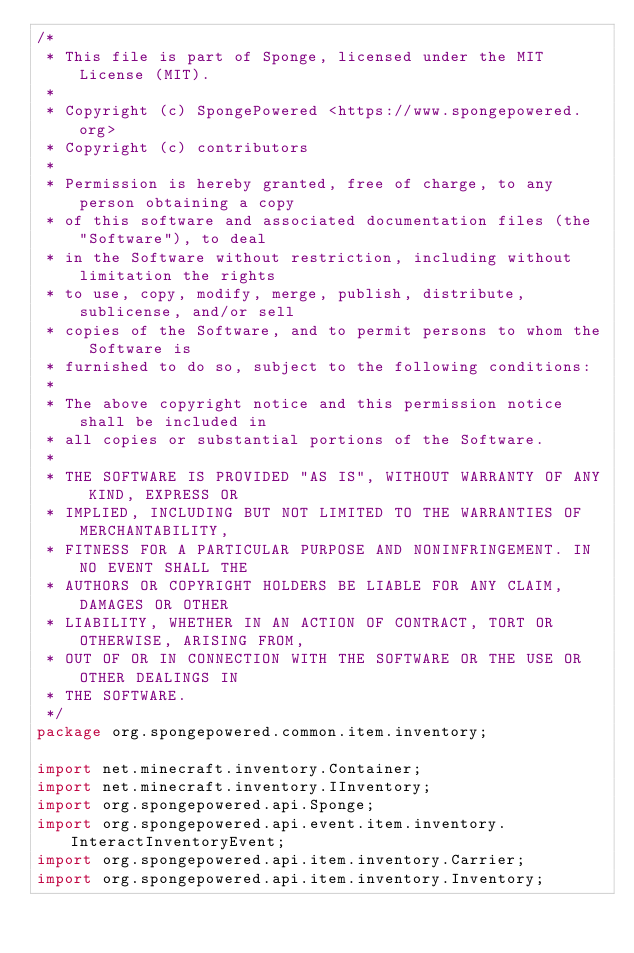<code> <loc_0><loc_0><loc_500><loc_500><_Java_>/*
 * This file is part of Sponge, licensed under the MIT License (MIT).
 *
 * Copyright (c) SpongePowered <https://www.spongepowered.org>
 * Copyright (c) contributors
 *
 * Permission is hereby granted, free of charge, to any person obtaining a copy
 * of this software and associated documentation files (the "Software"), to deal
 * in the Software without restriction, including without limitation the rights
 * to use, copy, modify, merge, publish, distribute, sublicense, and/or sell
 * copies of the Software, and to permit persons to whom the Software is
 * furnished to do so, subject to the following conditions:
 *
 * The above copyright notice and this permission notice shall be included in
 * all copies or substantial portions of the Software.
 *
 * THE SOFTWARE IS PROVIDED "AS IS", WITHOUT WARRANTY OF ANY KIND, EXPRESS OR
 * IMPLIED, INCLUDING BUT NOT LIMITED TO THE WARRANTIES OF MERCHANTABILITY,
 * FITNESS FOR A PARTICULAR PURPOSE AND NONINFRINGEMENT. IN NO EVENT SHALL THE
 * AUTHORS OR COPYRIGHT HOLDERS BE LIABLE FOR ANY CLAIM, DAMAGES OR OTHER
 * LIABILITY, WHETHER IN AN ACTION OF CONTRACT, TORT OR OTHERWISE, ARISING FROM,
 * OUT OF OR IN CONNECTION WITH THE SOFTWARE OR THE USE OR OTHER DEALINGS IN
 * THE SOFTWARE.
 */
package org.spongepowered.common.item.inventory;

import net.minecraft.inventory.Container;
import net.minecraft.inventory.IInventory;
import org.spongepowered.api.Sponge;
import org.spongepowered.api.event.item.inventory.InteractInventoryEvent;
import org.spongepowered.api.item.inventory.Carrier;
import org.spongepowered.api.item.inventory.Inventory;</code> 